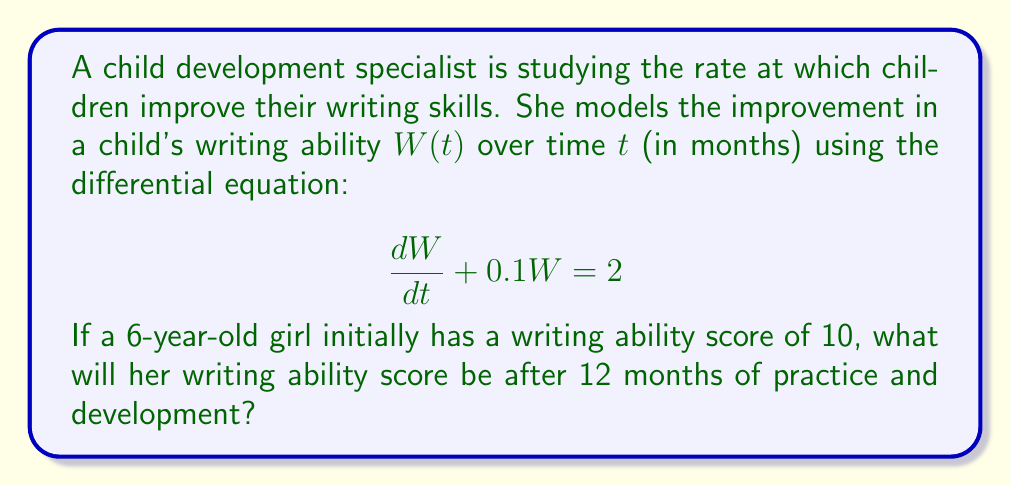Teach me how to tackle this problem. To solve this first-order linear differential equation, we'll follow these steps:

1) The general form of a first-order linear differential equation is:
   $$\frac{dy}{dx} + P(x)y = Q(x)$$

   In our case, $\frac{dW}{dt} + 0.1W = 2$, so $P(t) = 0.1$ and $Q(t) = 2$.

2) The integrating factor is $e^{\int P(t) dt} = e^{\int 0.1 dt} = e^{0.1t}$

3) Multiply both sides of the equation by the integrating factor:
   $$e^{0.1t}\frac{dW}{dt} + 0.1e^{0.1t}W = 2e^{0.1t}$$

4) The left side is now the derivative of $e^{0.1t}W$:
   $$\frac{d}{dt}(e^{0.1t}W) = 2e^{0.1t}$$

5) Integrate both sides:
   $$e^{0.1t}W = 20e^{0.1t} + C$$

6) Solve for W:
   $$W = 20 + Ce^{-0.1t}$$

7) Use the initial condition: When $t=0$, $W=10$
   $$10 = 20 + C$$
   $$C = -10$$

8) The particular solution is:
   $$W = 20 - 10e^{-0.1t}$$

9) To find W after 12 months, substitute $t=12$:
   $$W(12) = 20 - 10e^{-0.1(12)} \approx 18.87$$
Answer: After 12 months, the girl's writing ability score will be approximately 18.87. 